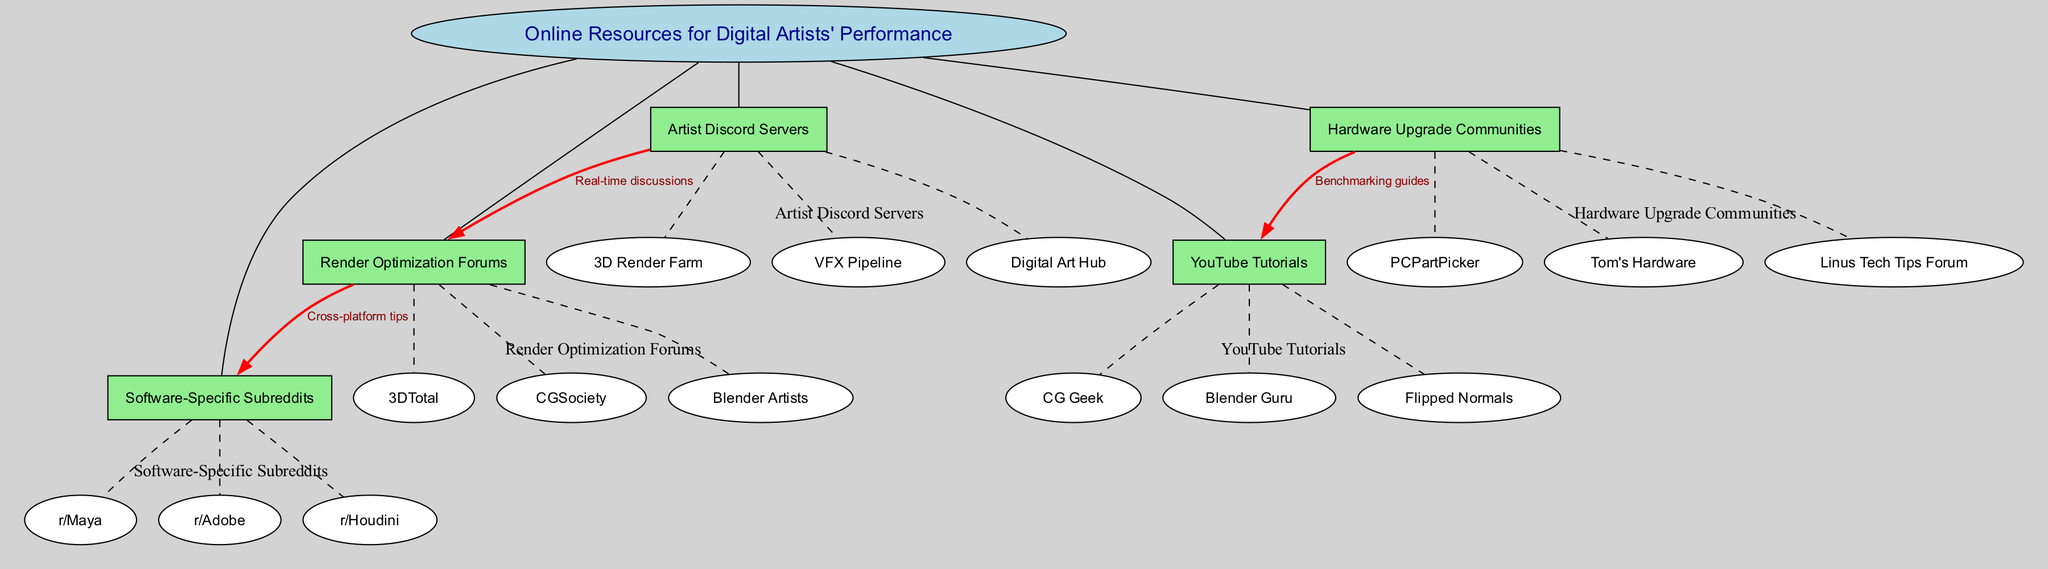What is the central topic of the concept map? The central topic is mentioned at the center of the diagram, and it is labeled as “Online Resources for Digital Artists' Performance”.
Answer: Online Resources for Digital Artists' Performance How many main nodes are present in the diagram? By counting the items listed under “mainNodes”, we find five main nodes: Render Optimization Forums, Hardware Upgrade Communities, Software-Specific Subreddits, YouTube Tutorials, and Artist Discord Servers.
Answer: 5 Which forum is associated with render optimization? The "Render Optimization Forums" node lists CGSociety, Blender Artists, and 3DTotal as the subnodes. Therefore, any of these forums could be referred to, but typically "CGSociety" is recognized as a popular option for this purpose.
Answer: CGSociety What connection is labeled as "Benchmarking guides"? The connection labeled "Benchmarking guides" is between "Hardware Upgrade Communities" and "YouTube Tutorials". This indicates that resources from hardware communities are linked to tutorial content on YouTube.
Answer: Benchmarking guides Which Discord server is connected to render optimization forums? The “Artist Discord Servers” node connects to “Render Optimization Forums” with a label "Real-time discussions." This indicates that discussions are happening in real-time within this community.
Answer: Digital Art Hub What is the relationship between render optimization forums and software-specific subreddits? The relationship is labeled as "Cross-platform tips", indicating that insights or advice that may apply across various software platforms are shared between these two nodes.
Answer: Cross-platform tips How many YouTube tutorial sources are mentioned in the diagram? The "YouTube Tutorials" main node lists three sources: Flipped Normals, CG Geek, and Blender Guru. Counting these gives us a total of three distinct sources.
Answer: 3 Which is the main node that discusses hardware upgrades? The “Hardware Upgrade Communities” main node encapsulates this area, and it includes related subnodes that contribute to discussions about hardware upgrades.
Answer: Hardware Upgrade Communities Which online community focuses on performance tips for digital artists? The main node encapsulating performance tips for digital artists is “Render Optimization Forums," which specifically provides forums for such tips.
Answer: Render Optimization Forums 